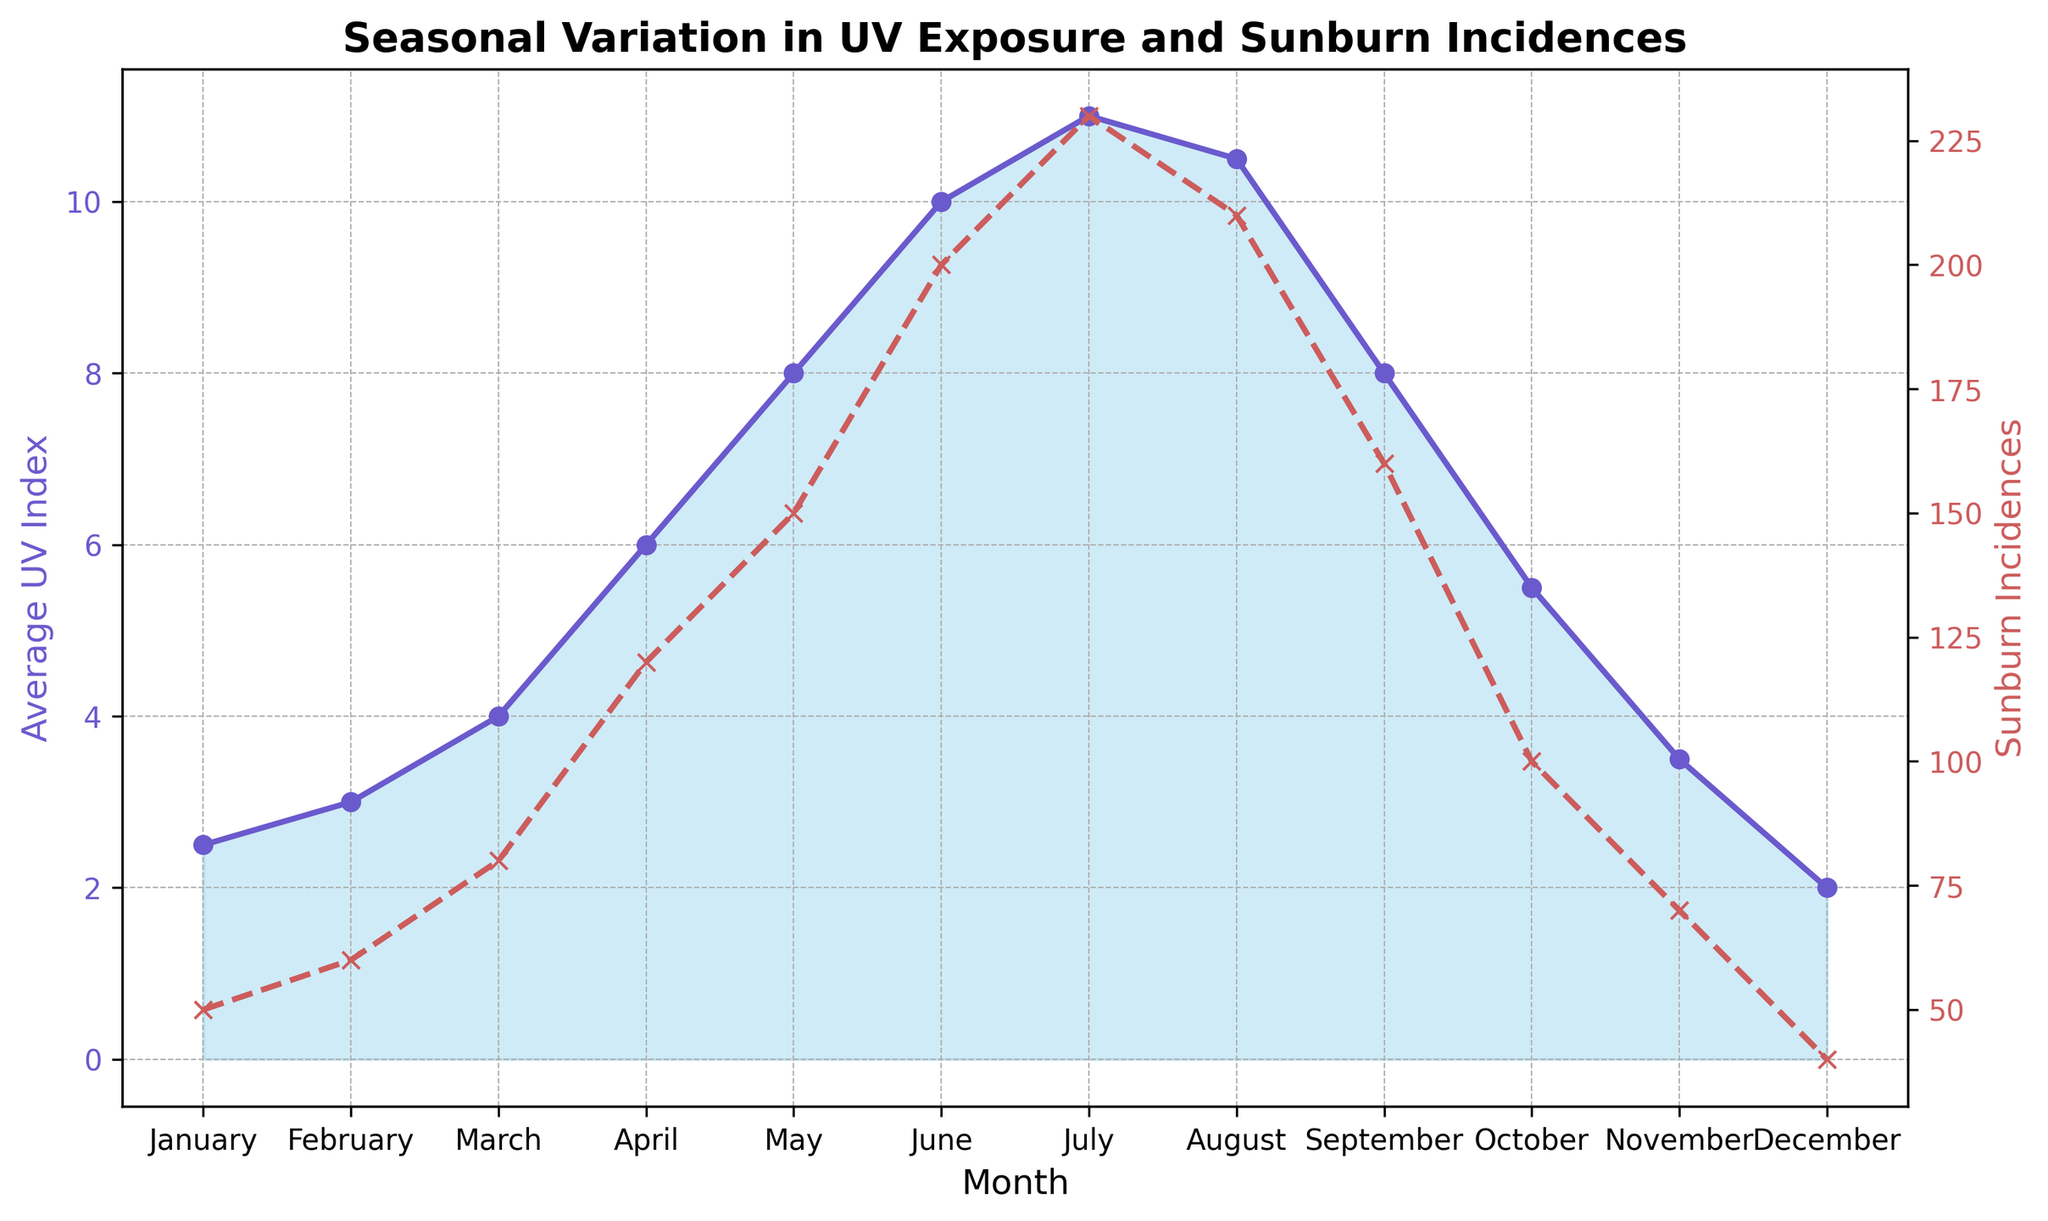What is the month with the highest Average UV Index? By looking at the area chart, the month with the highest point on the UV Index curve is July.
Answer: July Which months have a UV Index greater than 8.0? Observing the area chart for months where the UV Index line crosses above 8.0 reveals these months as May, June, July, and August.
Answer: May, June, July, August During which month do we see the sharpest rise in Sunburn Incidences? Examine the line representing Sunburn Incidences for the steepest increase between points. The sharpest rise is from May to June.
Answer: From May to June What is the approximate difference in Sunburn Incidences between July and January? Comparing the Sunburn Incidences points for July (230) and January (50), the difference is calculated as 230 - 50 = 180.
Answer: 180 How does the UV Index in December compare to October? Looking at the UV Index for December (2.0) and October (5.5), December has a lower value.
Answer: December is lower What overall pattern can be seen in the UV Index and Sunburn Incidences from January to December? The UV Index and Sunburn Incidences both start low in January, rise to a peak in mid-summer (July), and then decrease again by December.
Answer: Peaks in summer, lowest in winter Are there any months where the Sunburn Incidences line intersects the UV Index line? Observe the points where the dashed Sunburn Incidences line crosses the solid UV Index line. There are no intersections.
Answer: No What is the combined total of Sunburn Incidences for January and February? Add the incidences from January (50) and February (60) to get 50 + 60 = 110.
Answer: 110 How does the visual representation of the UV Index in August compare to June? The area under the UV Index line in August (10.5) is slightly less than in June (10.0), though it remains close in value.
Answer: August is slightly lower than June What trend is seen in Sunburn Incidences as the UV Index decreases from August to December? The trend shows a noticeable decline in Sunburn Incidences as the UV Index reduces from August (210) to December (40).
Answer: Decreasing trend 